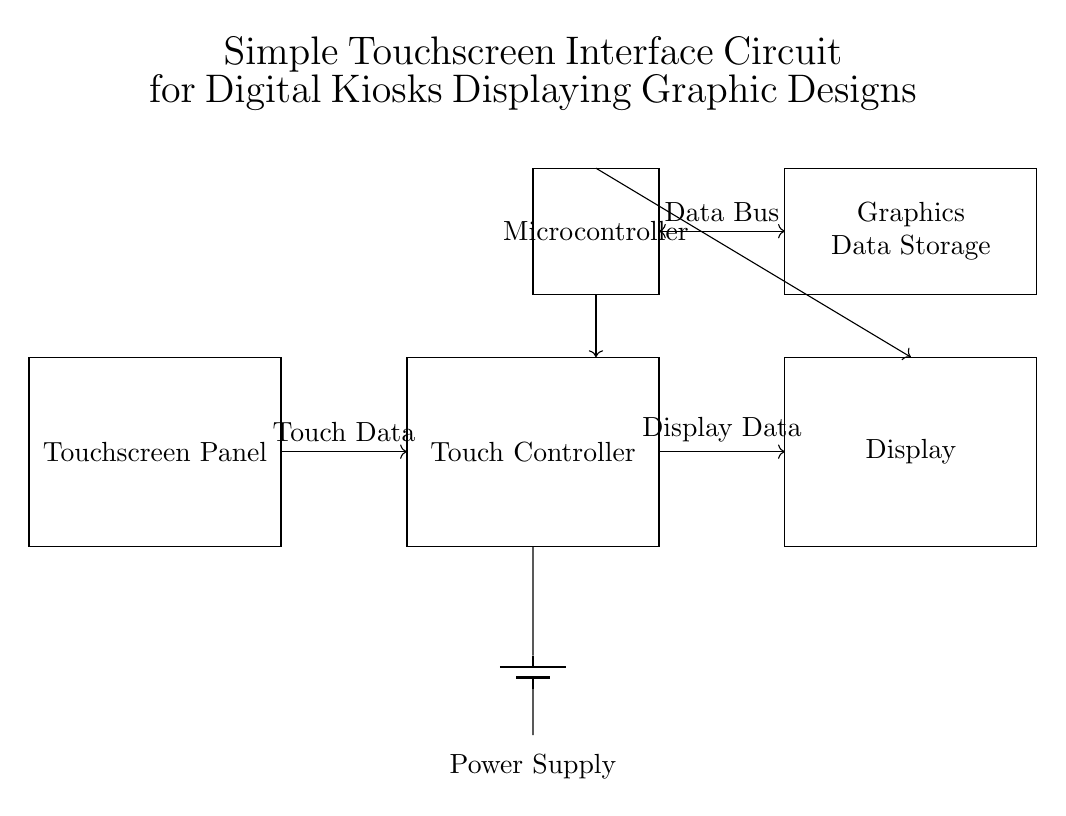What components are present in the circuit? The circuit contains a touchscreen panel, a touch controller, a display, a power supply, a microcontroller, and graphics data storage. These components are depicted as rectangles in the diagram.
Answer: touchscreen panel, touch controller, display, power supply, microcontroller, graphics data storage How is power supplied in this circuit? Power is supplied by a battery, which is represented in the diagram with a battery symbol connected to the microcontroller and other elements, indicating the direction of power flow.
Answer: battery What data does the touchscreen send? The touchscreen panel sends touch data to the touch controller as indicated by the arrow labeled "Touch Data" connecting the two components in the circuit.
Answer: Touch Data Which component receives display data? The display receives display data from the touch controller, as shown by the arrow labeled "Display Data" directed from the touch controller to the display module.
Answer: Display What is the purpose of the microcontroller in this circuit? The microcontroller processes the touch data from the touchscreen and sends the corresponding graphics data to the display, while also being connected to the graphics data storage unit.
Answer: Process touch data How does the graphics data storage communicate with the microcontroller? The graphics data storage communicates with the microcontroller via a data bus, as shown by the double-headed arrow labeled "Data Bus" between these two components in the circuit diagram.
Answer: Data Bus What assumption can we make about the operation of this circuit? This circuit assumes that when a user interacts with the touchscreen, the touch data is accurately detected, processed by the microcontroller, and displayed accordingly on the display, allowing for an interactive experience.
Answer: Interactive experience 